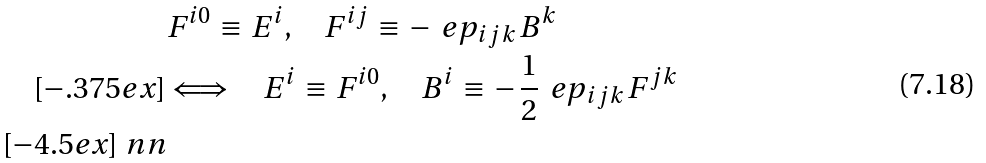<formula> <loc_0><loc_0><loc_500><loc_500>& F ^ { i 0 } \, \equiv \, E ^ { i } , \quad F ^ { i j } \, \equiv \, - \, \ e p _ { i j k } \, B ^ { k } \\ [ - . 3 7 5 e x ] & \Longleftrightarrow \quad E ^ { i } \, \equiv \, F ^ { i 0 } , \quad B ^ { i } \, \equiv \, - \, \frac { 1 } { 2 } \, \ e p _ { i j k } \, F ^ { j k } \\ [ - 4 . 5 e x ] \ n n</formula> 